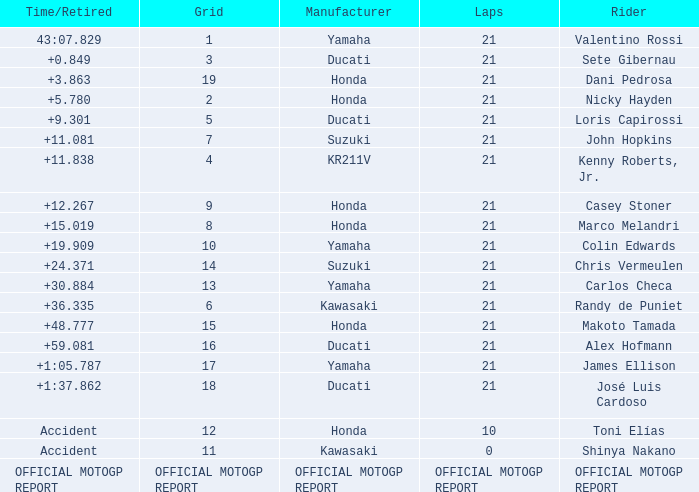How many laps did Valentino rossi have when riding a vehicle manufactured by yamaha? 21.0. 